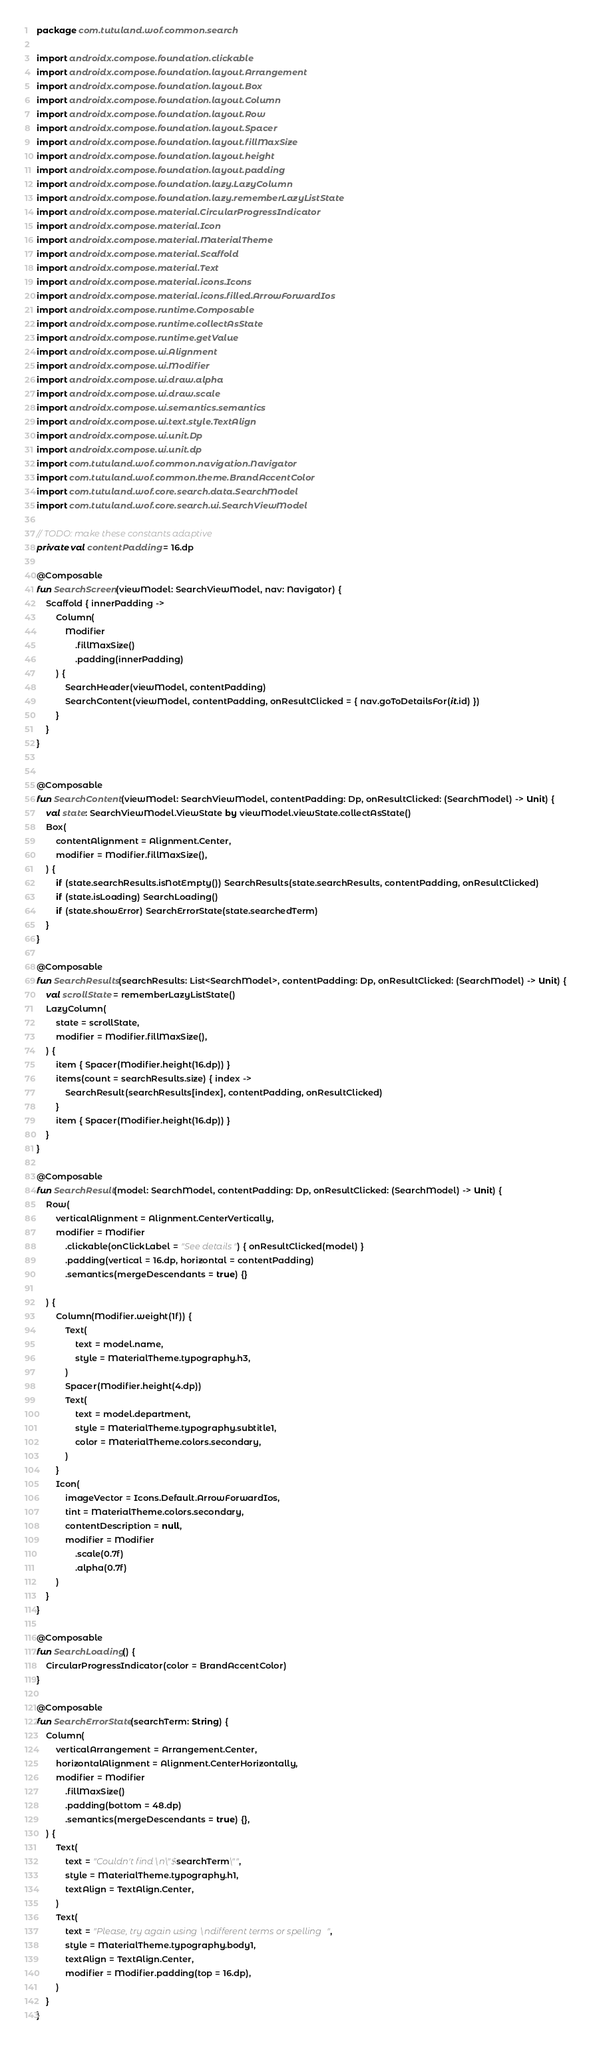<code> <loc_0><loc_0><loc_500><loc_500><_Kotlin_>package com.tutuland.wof.common.search

import androidx.compose.foundation.clickable
import androidx.compose.foundation.layout.Arrangement
import androidx.compose.foundation.layout.Box
import androidx.compose.foundation.layout.Column
import androidx.compose.foundation.layout.Row
import androidx.compose.foundation.layout.Spacer
import androidx.compose.foundation.layout.fillMaxSize
import androidx.compose.foundation.layout.height
import androidx.compose.foundation.layout.padding
import androidx.compose.foundation.lazy.LazyColumn
import androidx.compose.foundation.lazy.rememberLazyListState
import androidx.compose.material.CircularProgressIndicator
import androidx.compose.material.Icon
import androidx.compose.material.MaterialTheme
import androidx.compose.material.Scaffold
import androidx.compose.material.Text
import androidx.compose.material.icons.Icons
import androidx.compose.material.icons.filled.ArrowForwardIos
import androidx.compose.runtime.Composable
import androidx.compose.runtime.collectAsState
import androidx.compose.runtime.getValue
import androidx.compose.ui.Alignment
import androidx.compose.ui.Modifier
import androidx.compose.ui.draw.alpha
import androidx.compose.ui.draw.scale
import androidx.compose.ui.semantics.semantics
import androidx.compose.ui.text.style.TextAlign
import androidx.compose.ui.unit.Dp
import androidx.compose.ui.unit.dp
import com.tutuland.wof.common.navigation.Navigator
import com.tutuland.wof.common.theme.BrandAccentColor
import com.tutuland.wof.core.search.data.SearchModel
import com.tutuland.wof.core.search.ui.SearchViewModel

// TODO: make these constants adaptive
private val contentPadding = 16.dp

@Composable
fun SearchScreen(viewModel: SearchViewModel, nav: Navigator) {
    Scaffold { innerPadding ->
        Column(
            Modifier
                .fillMaxSize()
                .padding(innerPadding)
        ) {
            SearchHeader(viewModel, contentPadding)
            SearchContent(viewModel, contentPadding, onResultClicked = { nav.goToDetailsFor(it.id) })
        }
    }
}


@Composable
fun SearchContent(viewModel: SearchViewModel, contentPadding: Dp, onResultClicked: (SearchModel) -> Unit) {
    val state: SearchViewModel.ViewState by viewModel.viewState.collectAsState()
    Box(
        contentAlignment = Alignment.Center,
        modifier = Modifier.fillMaxSize(),
    ) {
        if (state.searchResults.isNotEmpty()) SearchResults(state.searchResults, contentPadding, onResultClicked)
        if (state.isLoading) SearchLoading()
        if (state.showError) SearchErrorState(state.searchedTerm)
    }
}

@Composable
fun SearchResults(searchResults: List<SearchModel>, contentPadding: Dp, onResultClicked: (SearchModel) -> Unit) {
    val scrollState = rememberLazyListState()
    LazyColumn(
        state = scrollState,
        modifier = Modifier.fillMaxSize(),
    ) {
        item { Spacer(Modifier.height(16.dp)) }
        items(count = searchResults.size) { index ->
            SearchResult(searchResults[index], contentPadding, onResultClicked)
        }
        item { Spacer(Modifier.height(16.dp)) }
    }
}

@Composable
fun SearchResult(model: SearchModel, contentPadding: Dp, onResultClicked: (SearchModel) -> Unit) {
    Row(
        verticalAlignment = Alignment.CenterVertically,
        modifier = Modifier
            .clickable(onClickLabel = "See details") { onResultClicked(model) }
            .padding(vertical = 16.dp, horizontal = contentPadding)
            .semantics(mergeDescendants = true) {}

    ) {
        Column(Modifier.weight(1f)) {
            Text(
                text = model.name,
                style = MaterialTheme.typography.h3,
            )
            Spacer(Modifier.height(4.dp))
            Text(
                text = model.department,
                style = MaterialTheme.typography.subtitle1,
                color = MaterialTheme.colors.secondary,
            )
        }
        Icon(
            imageVector = Icons.Default.ArrowForwardIos,
            tint = MaterialTheme.colors.secondary,
            contentDescription = null,
            modifier = Modifier
                .scale(0.7f)
                .alpha(0.7f)
        )
    }
}

@Composable
fun SearchLoading() {
    CircularProgressIndicator(color = BrandAccentColor)
}

@Composable
fun SearchErrorState(searchTerm: String) {
    Column(
        verticalArrangement = Arrangement.Center,
        horizontalAlignment = Alignment.CenterHorizontally,
        modifier = Modifier
            .fillMaxSize()
            .padding(bottom = 48.dp)
            .semantics(mergeDescendants = true) {},
    ) {
        Text(
            text = "Couldn't find\n\"$searchTerm\"",
            style = MaterialTheme.typography.h1,
            textAlign = TextAlign.Center,
        )
        Text(
            text = "Please, try again using\ndifferent terms or spelling",
            style = MaterialTheme.typography.body1,
            textAlign = TextAlign.Center,
            modifier = Modifier.padding(top = 16.dp),
        )
    }
}
</code> 